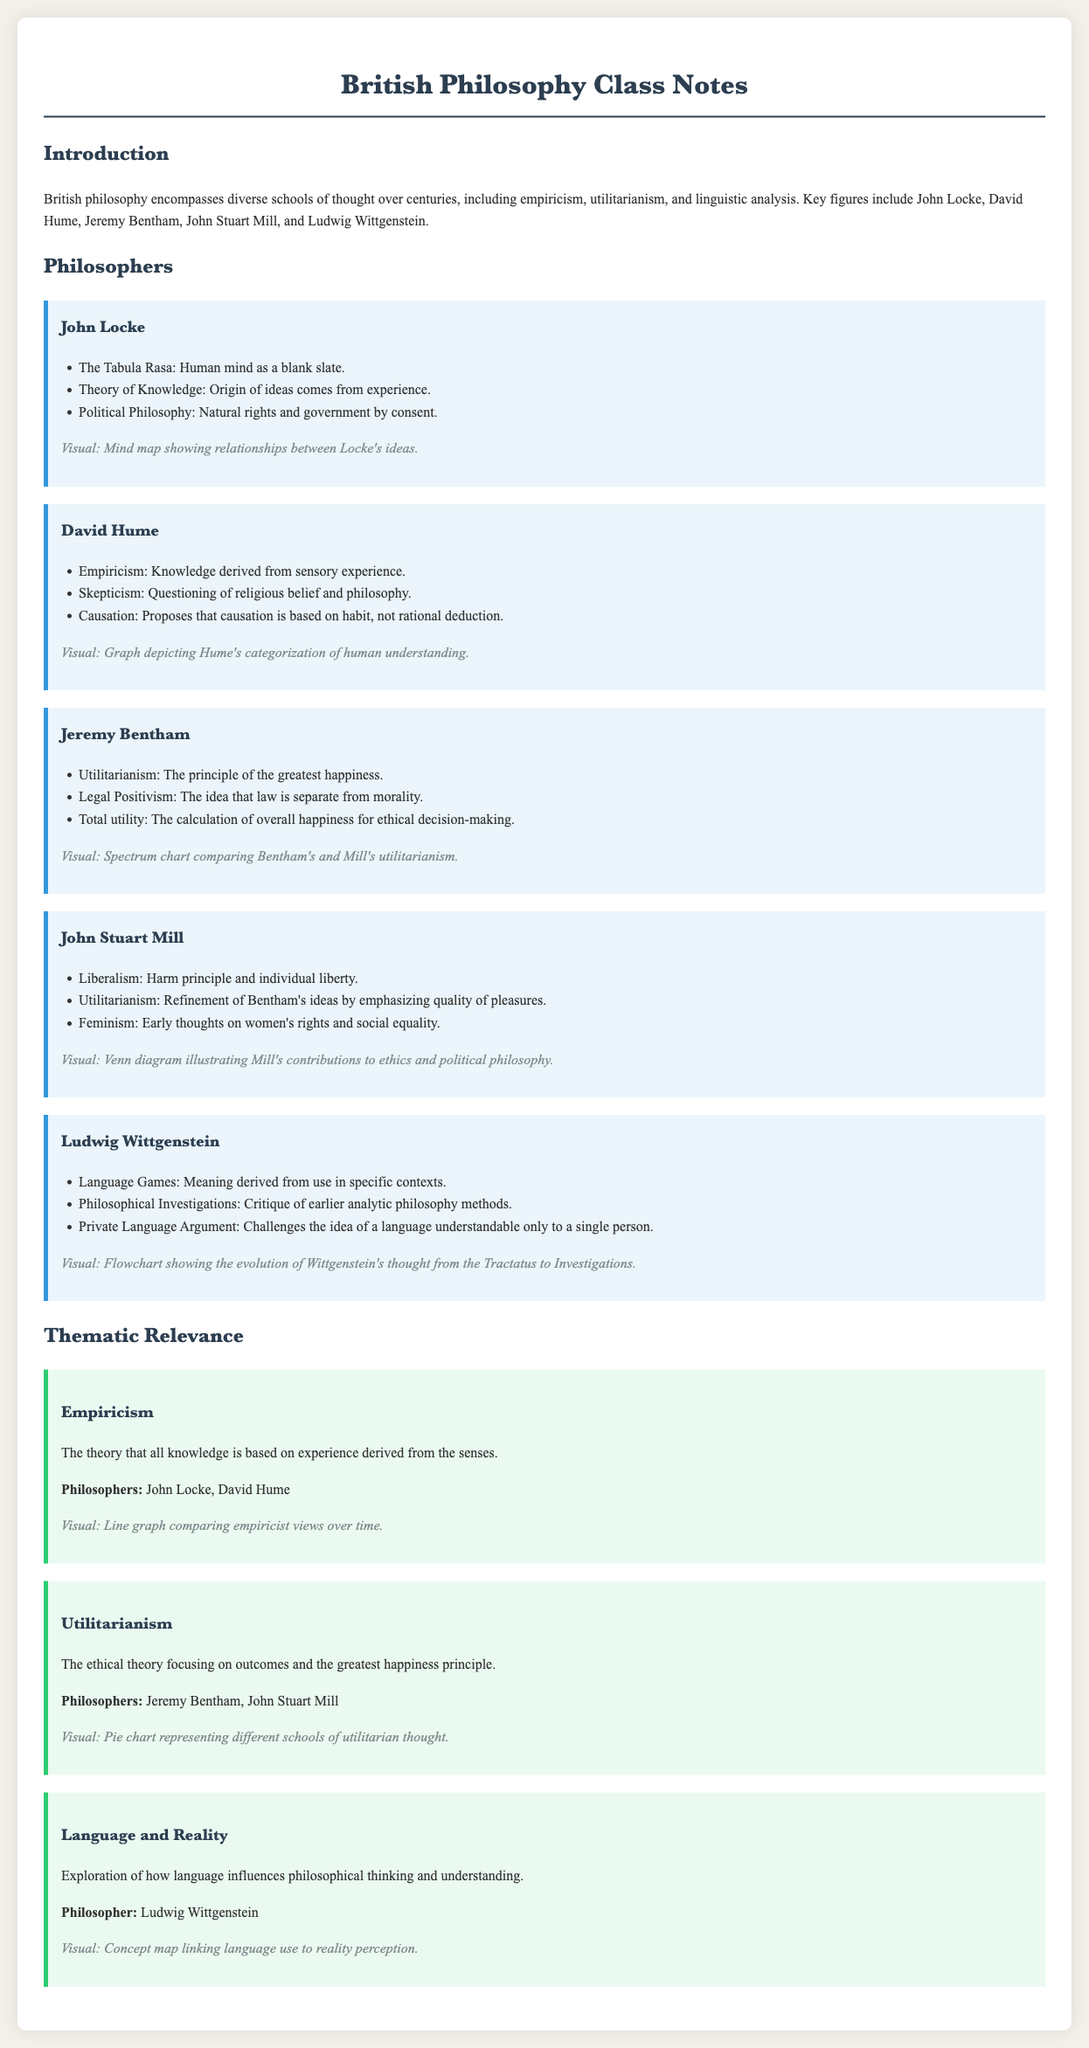What is the main topic of the class notes? The introduction section states that the class notes encompass diverse schools of thought in British philosophy.
Answer: British philosophy Who is associated with the idea of Tabula Rasa? The section on John Locke lists this concept as part of his theories.
Answer: John Locke What philosophical principle is Jeremy Bentham known for? Utilitarianism is prominently mentioned in Bentham's section detailing his ideas.
Answer: Utilitarianism Which philosopher's ideas relate to the skepticism of religious belief? David Hume's section highlights his questioning of religious belief.
Answer: David Hume What type of visual represents the comparison between Bentham's and Mill's utilitarianism? The document describes this visual as a spectrum chart.
Answer: Spectrum chart Under which theme is John Stuart Mill categorized in relation to ethics? The thematic relevance section highlights him under the theme of Utilitarianism.
Answer: Utilitarianism Which philosopher proposed the idea of language games? Ludwig Wittgenstein's section mentions this concept as part of his theories.
Answer: Ludwig Wittgenstein How many key philosophers are identified in the document? The introduction and sections list a total of five key philosophers.
Answer: Five What visual representation is used for the exploration of language and reality? The theme of Language and Reality is accompanied by a concept map.
Answer: Concept map 